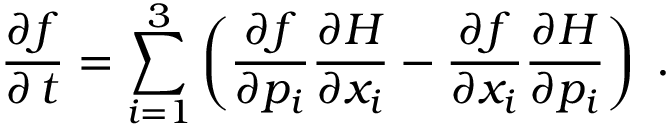Convert formula to latex. <formula><loc_0><loc_0><loc_500><loc_500>\frac { \partial f } { \partial \, t } = \sum _ { i = 1 } ^ { 3 } \left ( \frac { \partial f } { \partial p _ { i } } \frac { \partial H } { \partial x _ { i } } - \frac { \partial f } { \partial x _ { i } } \frac { \partial H } { \partial p _ { i } } \right ) \, .</formula> 